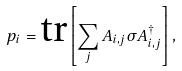Convert formula to latex. <formula><loc_0><loc_0><loc_500><loc_500>p _ { i } = { \text {tr} } \left [ \sum _ { j } { A _ { i , j } } \sigma A _ { i , j } ^ { \dagger } \right ] ,</formula> 